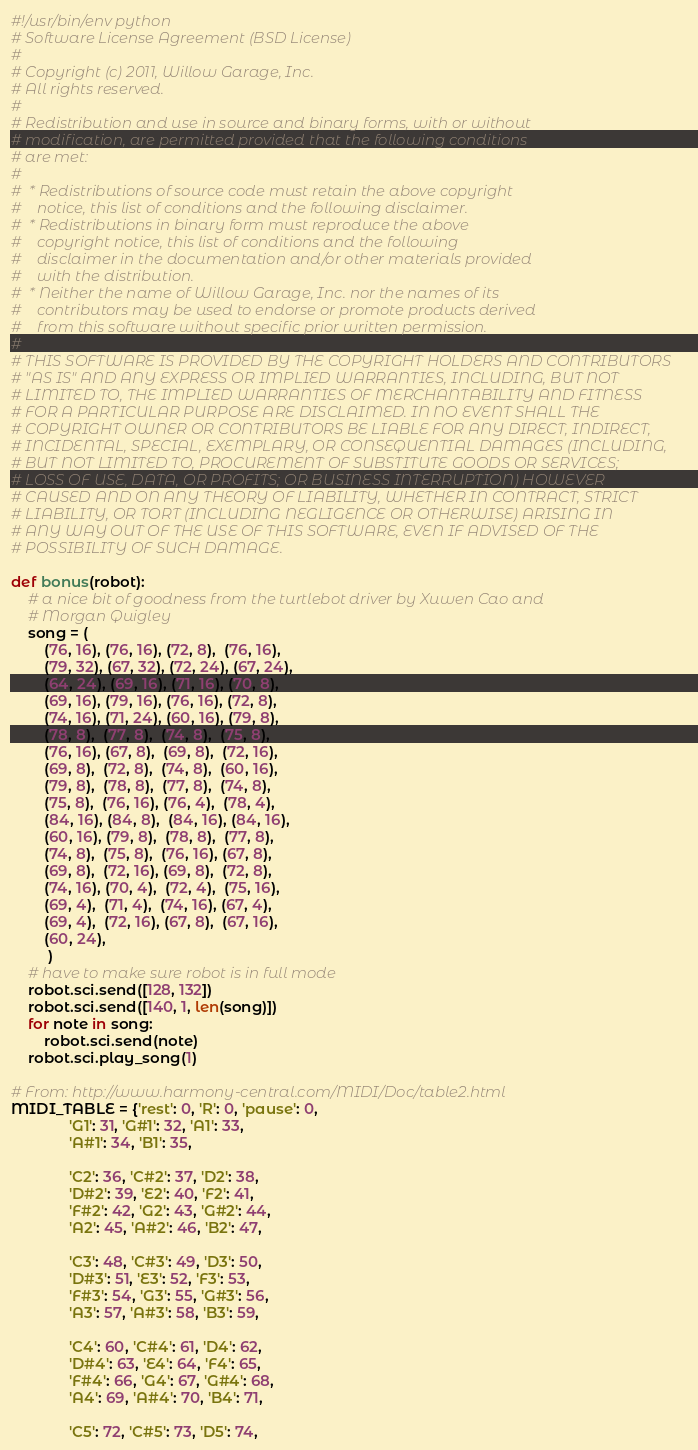Convert code to text. <code><loc_0><loc_0><loc_500><loc_500><_Python_>#!/usr/bin/env python
# Software License Agreement (BSD License)
#
# Copyright (c) 2011, Willow Garage, Inc.
# All rights reserved.
#
# Redistribution and use in source and binary forms, with or without
# modification, are permitted provided that the following conditions
# are met:
#
#  * Redistributions of source code must retain the above copyright
#    notice, this list of conditions and the following disclaimer.
#  * Redistributions in binary form must reproduce the above
#    copyright notice, this list of conditions and the following
#    disclaimer in the documentation and/or other materials provided
#    with the distribution.
#  * Neither the name of Willow Garage, Inc. nor the names of its
#    contributors may be used to endorse or promote products derived
#    from this software without specific prior written permission.
#
# THIS SOFTWARE IS PROVIDED BY THE COPYRIGHT HOLDERS AND CONTRIBUTORS
# "AS IS" AND ANY EXPRESS OR IMPLIED WARRANTIES, INCLUDING, BUT NOT
# LIMITED TO, THE IMPLIED WARRANTIES OF MERCHANTABILITY AND FITNESS
# FOR A PARTICULAR PURPOSE ARE DISCLAIMED. IN NO EVENT SHALL THE
# COPYRIGHT OWNER OR CONTRIBUTORS BE LIABLE FOR ANY DIRECT, INDIRECT,
# INCIDENTAL, SPECIAL, EXEMPLARY, OR CONSEQUENTIAL DAMAGES (INCLUDING,
# BUT NOT LIMITED TO, PROCUREMENT OF SUBSTITUTE GOODS OR SERVICES;
# LOSS OF USE, DATA, OR PROFITS; OR BUSINESS INTERRUPTION) HOWEVER
# CAUSED AND ON ANY THEORY OF LIABILITY, WHETHER IN CONTRACT, STRICT
# LIABILITY, OR TORT (INCLUDING NEGLIGENCE OR OTHERWISE) ARISING IN
# ANY WAY OUT OF THE USE OF THIS SOFTWARE, EVEN IF ADVISED OF THE
# POSSIBILITY OF SUCH DAMAGE.

def bonus(robot):
    # a nice bit of goodness from the turtlebot driver by Xuwen Cao and
    # Morgan Quigley
    song = (
        (76, 16), (76, 16), (72, 8),  (76, 16), 
        (79, 32), (67, 32), (72, 24), (67, 24), 	
        (64, 24), (69, 16), (71, 16), (70, 8), 
        (69, 16), (79, 16), (76, 16), (72, 8), 
        (74, 16), (71, 24), (60, 16), (79, 8), 
        (78, 8),  (77, 8),  (74, 8),  (75, 8), 
        (76, 16), (67, 8),  (69, 8),  (72, 16), 
        (69, 8),  (72, 8),  (74, 8),  (60, 16), 	
        (79, 8),  (78, 8),  (77, 8),  (74, 8), 
        (75, 8),  (76, 16), (76, 4),  (78, 4), 
        (84, 16), (84, 8),  (84, 16), (84, 16), 
        (60, 16), (79, 8),  (78, 8),  (77, 8), 
        (74, 8),  (75, 8),  (76, 16), (67, 8), 
        (69, 8),  (72, 16), (69, 8),  (72, 8), 
        (74, 16), (70, 4),  (72, 4),  (75, 16), 
        (69, 4),  (71, 4),  (74, 16), (67, 4), 
        (69, 4),  (72, 16), (67, 8),  (67, 16), 
        (60, 24),
         )
    # have to make sure robot is in full mode
    robot.sci.send([128, 132])
    robot.sci.send([140, 1, len(song)])
    for note in song:
        robot.sci.send(note)
    robot.sci.play_song(1)
    
# From: http://www.harmony-central.com/MIDI/Doc/table2.html
MIDI_TABLE = {'rest': 0, 'R': 0, 'pause': 0,
              'G1': 31, 'G#1': 32, 'A1': 33,
              'A#1': 34, 'B1': 35,

              'C2': 36, 'C#2': 37, 'D2': 38,
              'D#2': 39, 'E2': 40, 'F2': 41,
              'F#2': 42, 'G2': 43, 'G#2': 44,
              'A2': 45, 'A#2': 46, 'B2': 47,

              'C3': 48, 'C#3': 49, 'D3': 50,
              'D#3': 51, 'E3': 52, 'F3': 53,
              'F#3': 54, 'G3': 55, 'G#3': 56,
              'A3': 57, 'A#3': 58, 'B3': 59,

              'C4': 60, 'C#4': 61, 'D4': 62,
              'D#4': 63, 'E4': 64, 'F4': 65,
              'F#4': 66, 'G4': 67, 'G#4': 68,
              'A4': 69, 'A#4': 70, 'B4': 71,

              'C5': 72, 'C#5': 73, 'D5': 74,</code> 